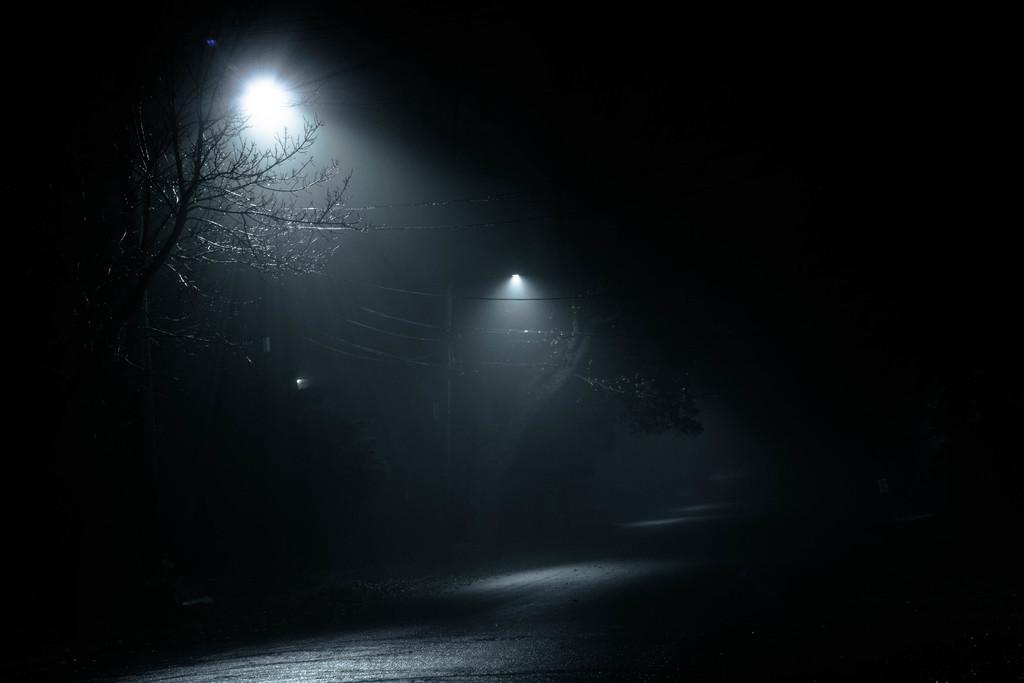What is the overall lighting condition in the image? The image is dark. Despite the darkness, what can be seen in the image? There are lights visible in the image. What structure is present in the image? There is a pole in the image. What else can be seen in the image besides the pole? There are wires and trees visible in the image. What suggestion does the pole make in the image? The pole does not make any suggestions in the image; it is a stationary structure. 